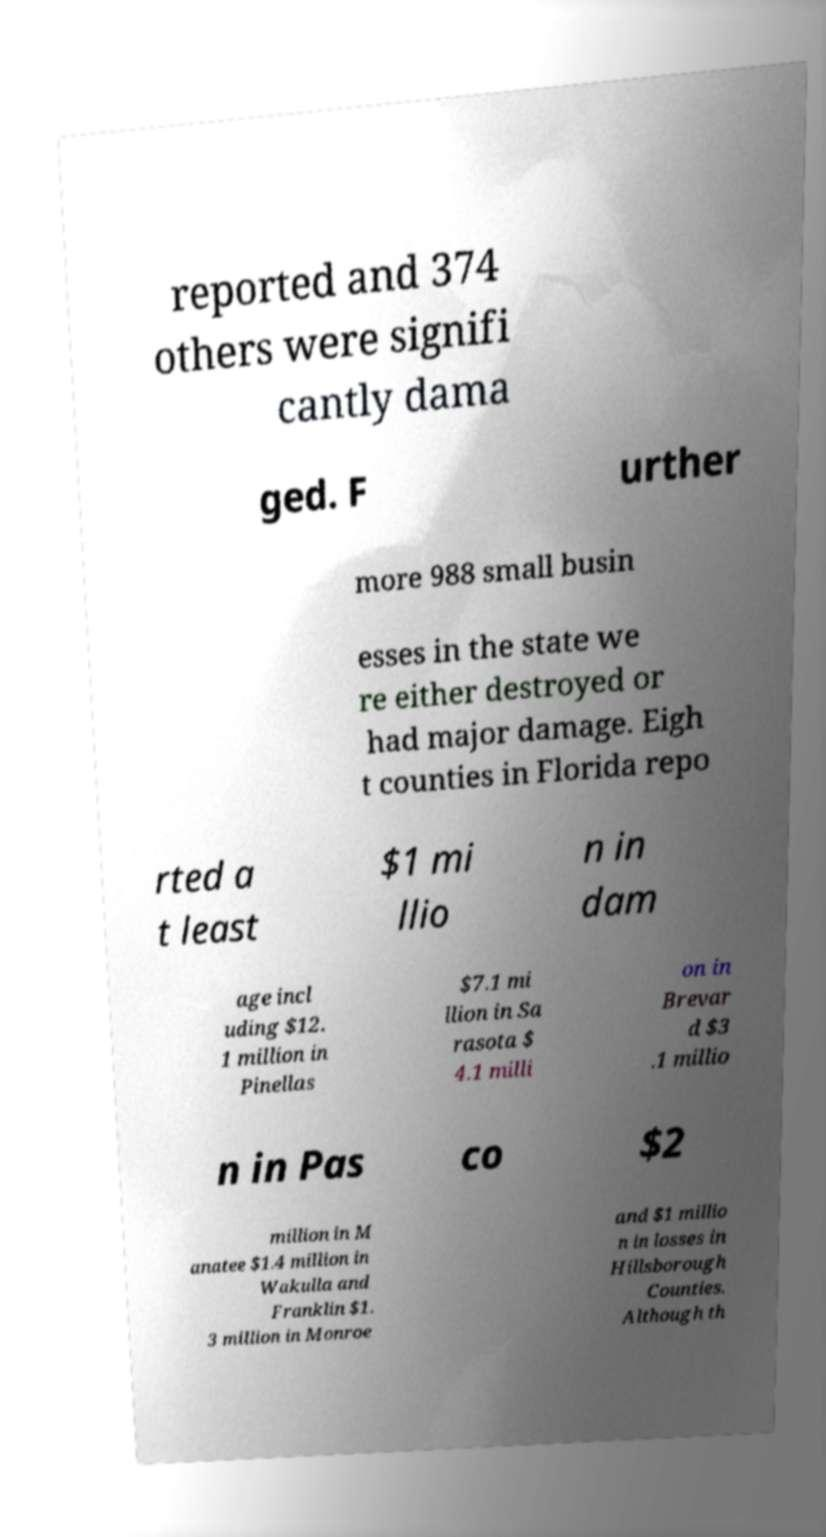Please read and relay the text visible in this image. What does it say? reported and 374 others were signifi cantly dama ged. F urther more 988 small busin esses in the state we re either destroyed or had major damage. Eigh t counties in Florida repo rted a t least $1 mi llio n in dam age incl uding $12. 1 million in Pinellas $7.1 mi llion in Sa rasota $ 4.1 milli on in Brevar d $3 .1 millio n in Pas co $2 million in M anatee $1.4 million in Wakulla and Franklin $1. 3 million in Monroe and $1 millio n in losses in Hillsborough Counties. Although th 